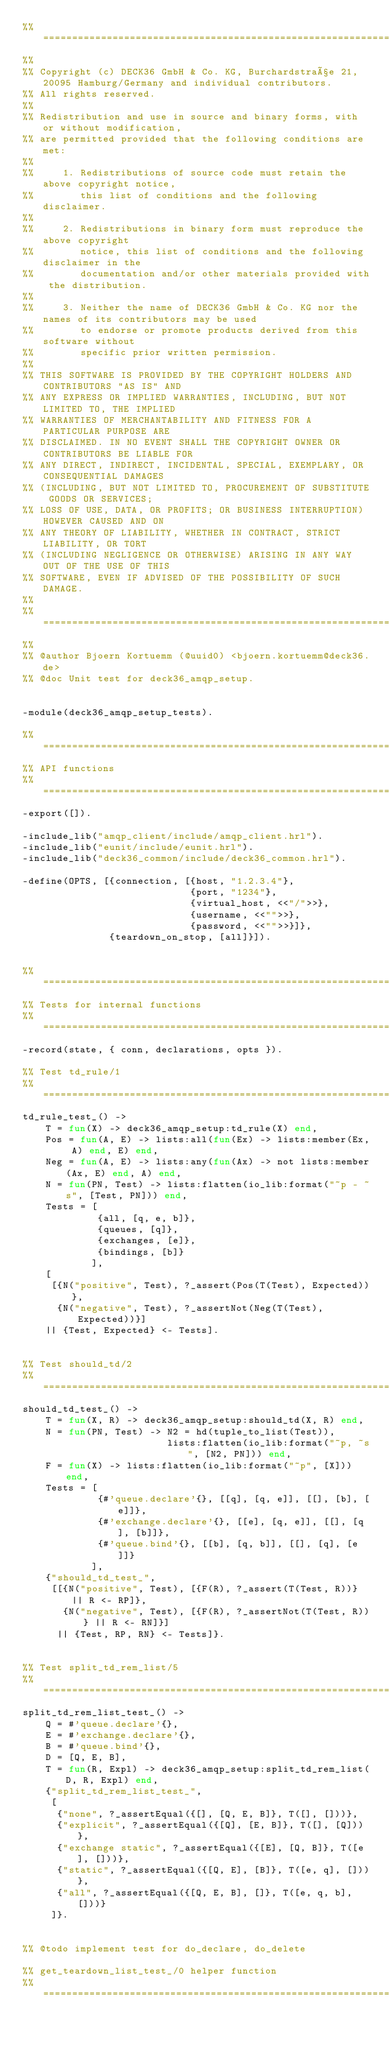<code> <loc_0><loc_0><loc_500><loc_500><_Erlang_>%% ====================================================================
%%
%% Copyright (c) DECK36 GmbH & Co. KG, Burchardstraße 21, 20095 Hamburg/Germany and individual contributors.
%% All rights reserved.
%% 
%% Redistribution and use in source and binary forms, with or without modification,
%% are permitted provided that the following conditions are met:
%% 
%%     1. Redistributions of source code must retain the above copyright notice,
%%        this list of conditions and the following disclaimer.
%% 
%%     2. Redistributions in binary form must reproduce the above copyright
%%        notice, this list of conditions and the following disclaimer in the
%%        documentation and/or other materials provided with the distribution.
%% 
%%     3. Neither the name of DECK36 GmbH & Co. KG nor the names of its contributors may be used
%%        to endorse or promote products derived from this software without
%%        specific prior written permission.
%% 
%% THIS SOFTWARE IS PROVIDED BY THE COPYRIGHT HOLDERS AND CONTRIBUTORS "AS IS" AND
%% ANY EXPRESS OR IMPLIED WARRANTIES, INCLUDING, BUT NOT LIMITED TO, THE IMPLIED
%% WARRANTIES OF MERCHANTABILITY AND FITNESS FOR A PARTICULAR PURPOSE ARE
%% DISCLAIMED. IN NO EVENT SHALL THE COPYRIGHT OWNER OR CONTRIBUTORS BE LIABLE FOR
%% ANY DIRECT, INDIRECT, INCIDENTAL, SPECIAL, EXEMPLARY, OR CONSEQUENTIAL DAMAGES
%% (INCLUDING, BUT NOT LIMITED TO, PROCUREMENT OF SUBSTITUTE GOODS OR SERVICES;
%% LOSS OF USE, DATA, OR PROFITS; OR BUSINESS INTERRUPTION) HOWEVER CAUSED AND ON
%% ANY THEORY OF LIABILITY, WHETHER IN CONTRACT, STRICT LIABILITY, OR TORT
%% (INCLUDING NEGLIGENCE OR OTHERWISE) ARISING IN ANY WAY OUT OF THE USE OF THIS
%% SOFTWARE, EVEN IF ADVISED OF THE POSSIBILITY OF SUCH DAMAGE.
%%
%% ====================================================================
%%
%% @author Bjoern Kortuemm (@uuid0) <bjoern.kortuemm@deck36.de>
%% @doc Unit test for deck36_amqp_setup.


-module(deck36_amqp_setup_tests).

%% ====================================================================
%% API functions
%% ====================================================================
-export([]).

-include_lib("amqp_client/include/amqp_client.hrl").
-include_lib("eunit/include/eunit.hrl").
-include_lib("deck36_common/include/deck36_common.hrl").

-define(OPTS, [{connection, [{host, "1.2.3.4"},
							 {port, "1234"},
							 {virtual_host, <<"/">>},
							 {username, <<"">>},
							 {password, <<"">>}]},
			   {teardown_on_stop, [all]}]).


%% ====================================================================
%% Tests for internal functions
%% ====================================================================
-record(state, { conn, declarations, opts }).

%% Test td_rule/1
%% ====================================================================
td_rule_test_() ->
	T = fun(X) -> deck36_amqp_setup:td_rule(X) end,
	Pos = fun(A, E) -> lists:all(fun(Ex) -> lists:member(Ex, A) end, E) end,
	Neg = fun(A, E) -> lists:any(fun(Ax) -> not lists:member(Ax, E) end, A) end,
	N = fun(PN, Test) -> lists:flatten(io_lib:format("~p - ~s", [Test, PN])) end,
	Tests = [
			 {all, [q, e, b]},
			 {queues, [q]},
			 {exchanges, [e]},
			 {bindings, [b]}
			],
	[
	 [{N("positive", Test), ?_assert(Pos(T(Test), Expected))},
	  {N("negative", Test), ?_assertNot(Neg(T(Test), Expected))}]
	|| {Test, Expected} <- Tests].


%% Test should_td/2
%% ====================================================================
should_td_test_() ->
	T = fun(X, R) -> deck36_amqp_setup:should_td(X, R) end,
	N = fun(PN, Test) -> N2 = hd(tuple_to_list(Test)),
						 lists:flatten(io_lib:format("~p, ~s", [N2, PN])) end,
	F = fun(X) -> lists:flatten(io_lib:format("~p", [X])) end,
	Tests = [
			 {#'queue.declare'{}, [[q], [q, e]], [[], [b], [e]]},
			 {#'exchange.declare'{}, [[e], [q, e]], [[], [q], [b]]},
			 {#'queue.bind'{}, [[b], [q, b]], [[], [q], [e]]}
			],
	{"should_td_test_",
	 [[{N("positive", Test), [{F(R), ?_assert(T(Test, R))} || R <- RP]},
	   {N("negative", Test), [{F(R), ?_assertNot(T(Test, R))} || R <- RN]}]
	  || {Test, RP, RN} <- Tests]}.


%% Test split_td_rem_list/5
%% ====================================================================
split_td_rem_list_test_() ->
	Q = #'queue.declare'{},
	E = #'exchange.declare'{},
	B = #'queue.bind'{},
	D = [Q, E, B],
	T = fun(R, Expl) -> deck36_amqp_setup:split_td_rem_list(D, R, Expl) end,
	{"split_td_rem_list_test_",
	 [
	  {"none", ?_assertEqual({[], [Q, E, B]}, T([], []))},   
	  {"explicit", ?_assertEqual({[Q], [E, B]}, T([], [Q]))},   
	  {"exchange static", ?_assertEqual({[E], [Q, B]}, T([e], []))},
	  {"static", ?_assertEqual({[Q, E], [B]}, T([e, q], []))},
	  {"all", ?_assertEqual({[Q, E, B], []}, T([e, q, b], []))}
	 ]}.   


%% @todo implement test for do_declare, do_delete

%% get_teardown_list_test_/0 helper function
%% ====================================================================</code> 